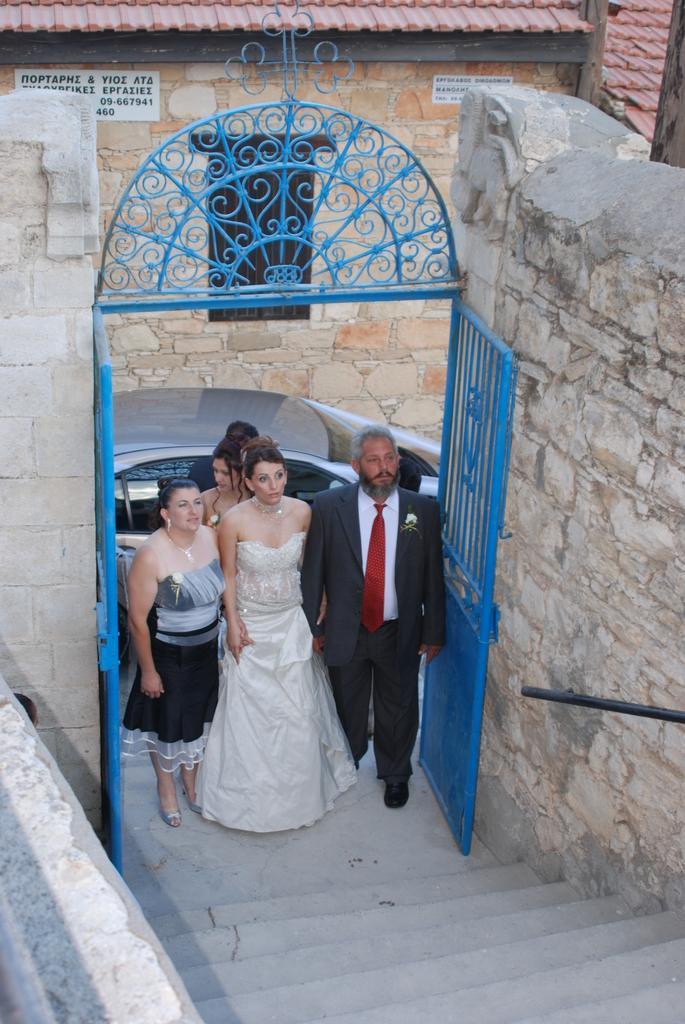How would you summarize this image in a sentence or two? In the picture we can see a man and a woman, a man is wearing a blazer, tie and shirt and a woman are wearing a white dress and besides, we can see some people and a car they are coming into the gate which is blue in color and steps near and to the sides we can see a wall and in the background we can see a house with a door. 